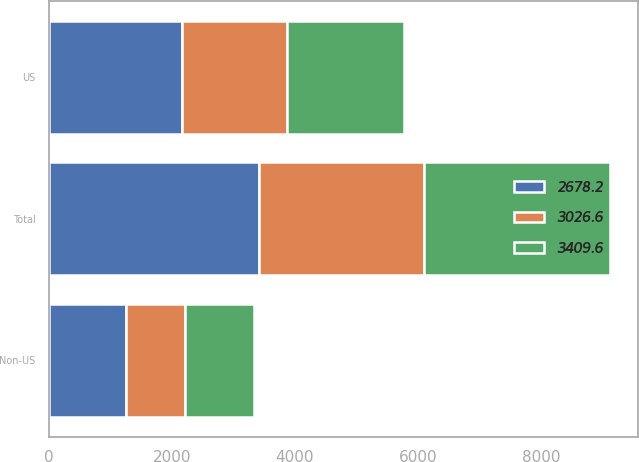<chart> <loc_0><loc_0><loc_500><loc_500><stacked_bar_chart><ecel><fcel>US<fcel>Non-US<fcel>Total<nl><fcel>2678.2<fcel>2160.8<fcel>1248.8<fcel>3409.6<nl><fcel>3409.6<fcel>1904.1<fcel>1122.5<fcel>3026.6<nl><fcel>3026.6<fcel>1711.9<fcel>966.3<fcel>2678.2<nl></chart> 